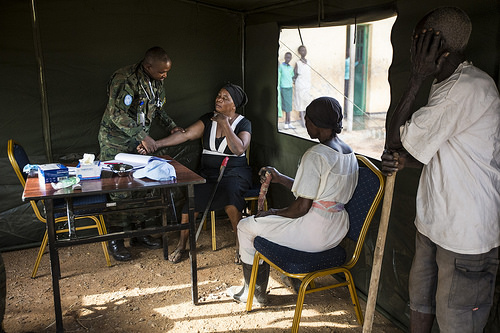<image>
Is there a walking stick to the right of the baseball cap? Yes. From this viewpoint, the walking stick is positioned to the right side relative to the baseball cap. 